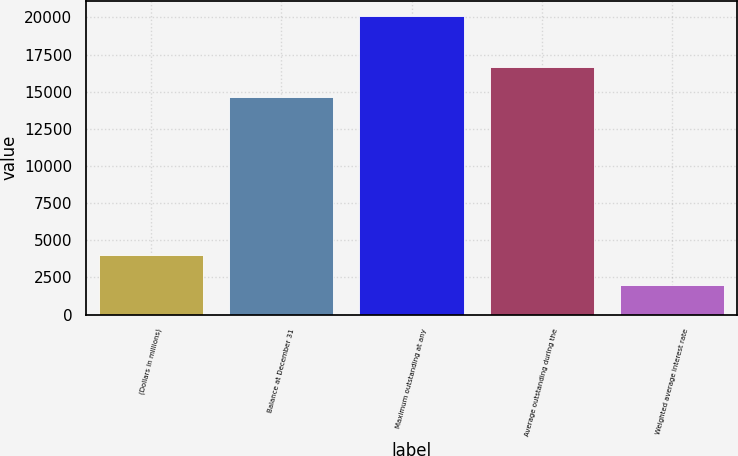<chart> <loc_0><loc_0><loc_500><loc_500><bar_chart><fcel>(Dollars in millions)<fcel>Balance at December 31<fcel>Maximum outstanding at any<fcel>Average outstanding during the<fcel>Weighted average interest rate<nl><fcel>4024.32<fcel>14646<fcel>20108<fcel>16656.5<fcel>2013.86<nl></chart> 